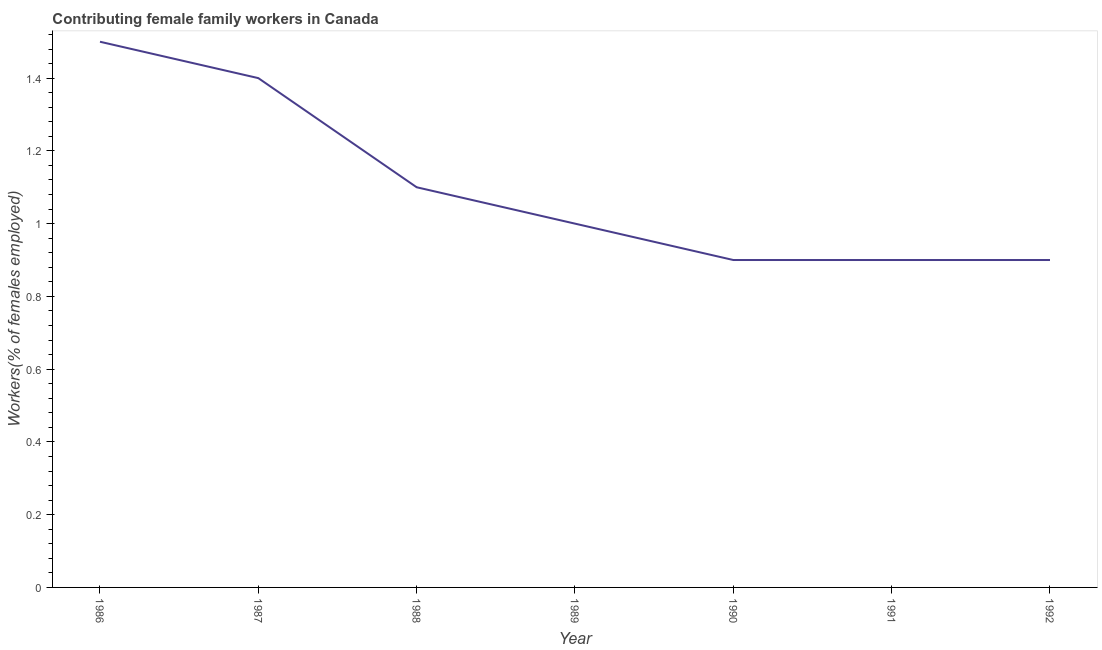What is the contributing female family workers in 1987?
Offer a terse response. 1.4. Across all years, what is the maximum contributing female family workers?
Provide a succinct answer. 1.5. Across all years, what is the minimum contributing female family workers?
Your response must be concise. 0.9. What is the sum of the contributing female family workers?
Ensure brevity in your answer.  7.7. What is the difference between the contributing female family workers in 1986 and 1988?
Offer a terse response. 0.4. What is the average contributing female family workers per year?
Your answer should be very brief. 1.1. What is the median contributing female family workers?
Your response must be concise. 1. What is the ratio of the contributing female family workers in 1987 to that in 1992?
Offer a terse response. 1.56. Is the contributing female family workers in 1990 less than that in 1992?
Ensure brevity in your answer.  No. What is the difference between the highest and the second highest contributing female family workers?
Your response must be concise. 0.1. What is the difference between the highest and the lowest contributing female family workers?
Keep it short and to the point. 0.6. How many lines are there?
Make the answer very short. 1. Does the graph contain any zero values?
Offer a terse response. No. What is the title of the graph?
Offer a terse response. Contributing female family workers in Canada. What is the label or title of the Y-axis?
Keep it short and to the point. Workers(% of females employed). What is the Workers(% of females employed) in 1987?
Your answer should be very brief. 1.4. What is the Workers(% of females employed) of 1988?
Provide a short and direct response. 1.1. What is the Workers(% of females employed) of 1989?
Your response must be concise. 1. What is the Workers(% of females employed) in 1990?
Give a very brief answer. 0.9. What is the Workers(% of females employed) in 1991?
Keep it short and to the point. 0.9. What is the Workers(% of females employed) of 1992?
Make the answer very short. 0.9. What is the difference between the Workers(% of females employed) in 1986 and 1989?
Provide a succinct answer. 0.5. What is the difference between the Workers(% of females employed) in 1986 and 1991?
Your response must be concise. 0.6. What is the difference between the Workers(% of females employed) in 1986 and 1992?
Your response must be concise. 0.6. What is the difference between the Workers(% of females employed) in 1987 and 1989?
Make the answer very short. 0.4. What is the difference between the Workers(% of females employed) in 1988 and 1990?
Ensure brevity in your answer.  0.2. What is the difference between the Workers(% of females employed) in 1989 and 1990?
Ensure brevity in your answer.  0.1. What is the difference between the Workers(% of females employed) in 1989 and 1991?
Keep it short and to the point. 0.1. What is the difference between the Workers(% of females employed) in 1990 and 1991?
Your answer should be compact. 0. What is the difference between the Workers(% of females employed) in 1990 and 1992?
Your response must be concise. 0. What is the difference between the Workers(% of females employed) in 1991 and 1992?
Provide a succinct answer. 0. What is the ratio of the Workers(% of females employed) in 1986 to that in 1987?
Make the answer very short. 1.07. What is the ratio of the Workers(% of females employed) in 1986 to that in 1988?
Your response must be concise. 1.36. What is the ratio of the Workers(% of females employed) in 1986 to that in 1989?
Make the answer very short. 1.5. What is the ratio of the Workers(% of females employed) in 1986 to that in 1990?
Make the answer very short. 1.67. What is the ratio of the Workers(% of females employed) in 1986 to that in 1991?
Your answer should be compact. 1.67. What is the ratio of the Workers(% of females employed) in 1986 to that in 1992?
Ensure brevity in your answer.  1.67. What is the ratio of the Workers(% of females employed) in 1987 to that in 1988?
Your answer should be compact. 1.27. What is the ratio of the Workers(% of females employed) in 1987 to that in 1989?
Provide a succinct answer. 1.4. What is the ratio of the Workers(% of females employed) in 1987 to that in 1990?
Ensure brevity in your answer.  1.56. What is the ratio of the Workers(% of females employed) in 1987 to that in 1991?
Your response must be concise. 1.56. What is the ratio of the Workers(% of females employed) in 1987 to that in 1992?
Give a very brief answer. 1.56. What is the ratio of the Workers(% of females employed) in 1988 to that in 1990?
Your answer should be very brief. 1.22. What is the ratio of the Workers(% of females employed) in 1988 to that in 1991?
Keep it short and to the point. 1.22. What is the ratio of the Workers(% of females employed) in 1988 to that in 1992?
Offer a terse response. 1.22. What is the ratio of the Workers(% of females employed) in 1989 to that in 1990?
Ensure brevity in your answer.  1.11. What is the ratio of the Workers(% of females employed) in 1989 to that in 1991?
Offer a very short reply. 1.11. What is the ratio of the Workers(% of females employed) in 1989 to that in 1992?
Give a very brief answer. 1.11. What is the ratio of the Workers(% of females employed) in 1990 to that in 1992?
Make the answer very short. 1. What is the ratio of the Workers(% of females employed) in 1991 to that in 1992?
Your answer should be compact. 1. 